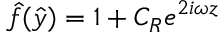<formula> <loc_0><loc_0><loc_500><loc_500>\hat { f } ( \hat { y } ) = 1 + C _ { R } e ^ { 2 i \omega z }</formula> 